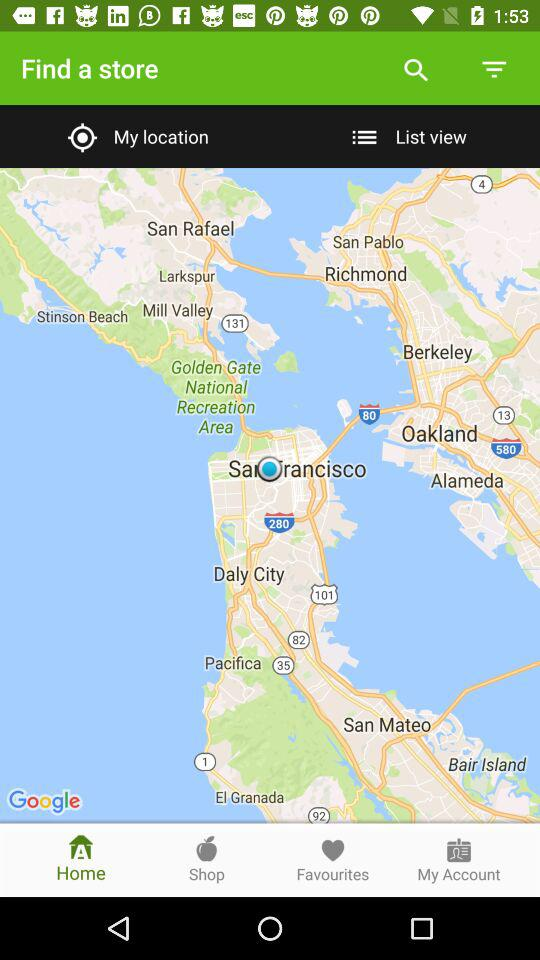Which tab has been selected? The selected tab is "Home". 